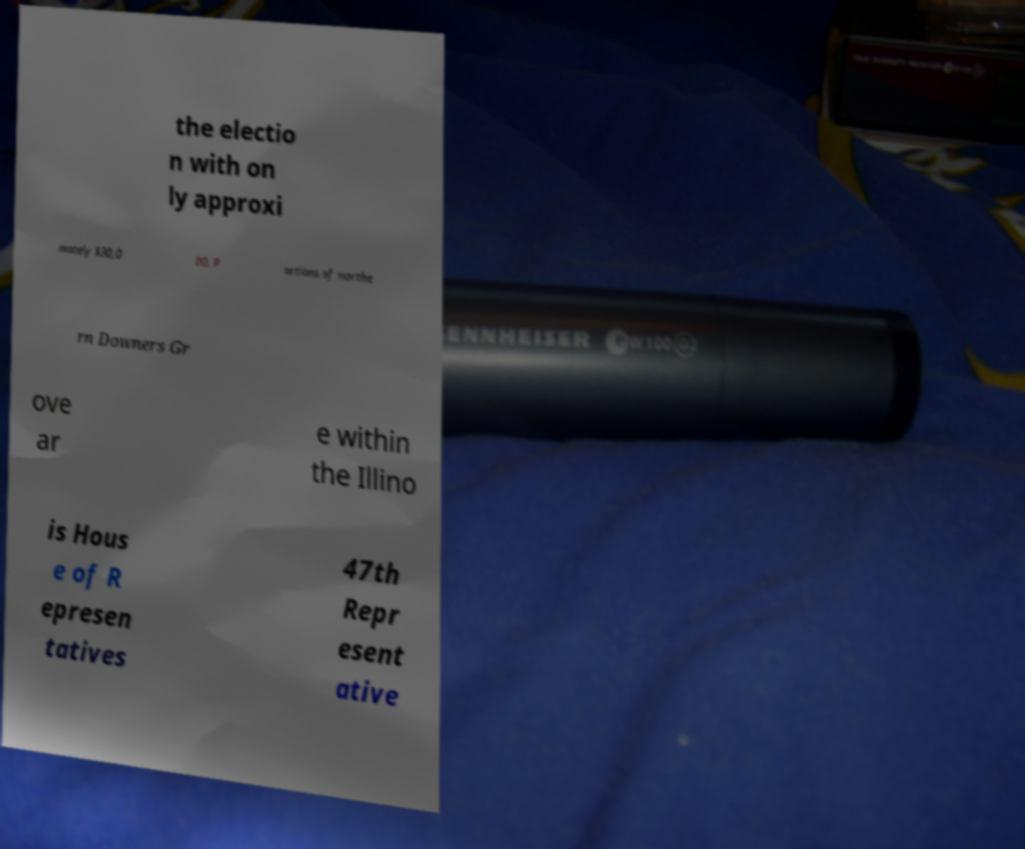What messages or text are displayed in this image? I need them in a readable, typed format. the electio n with on ly approxi mately $30,0 00. P ortions of northe rn Downers Gr ove ar e within the Illino is Hous e of R epresen tatives 47th Repr esent ative 